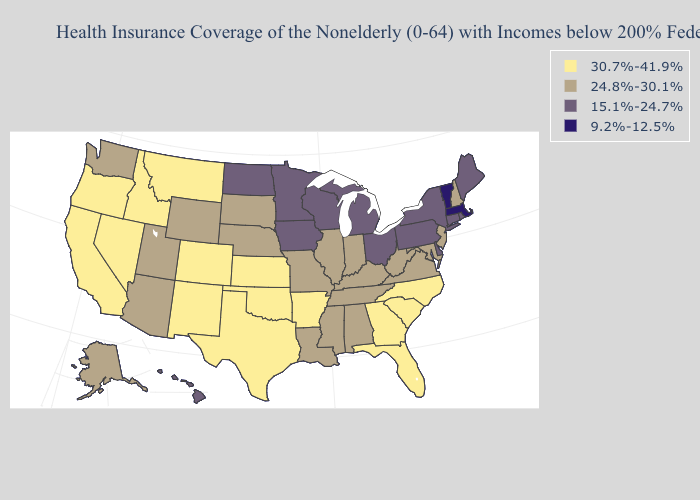Name the states that have a value in the range 9.2%-12.5%?
Be succinct. Massachusetts, Vermont. What is the lowest value in states that border North Dakota?
Write a very short answer. 15.1%-24.7%. What is the highest value in the South ?
Short answer required. 30.7%-41.9%. What is the value of Minnesota?
Write a very short answer. 15.1%-24.7%. Which states have the lowest value in the MidWest?
Write a very short answer. Iowa, Michigan, Minnesota, North Dakota, Ohio, Wisconsin. What is the highest value in the USA?
Keep it brief. 30.7%-41.9%. Does the first symbol in the legend represent the smallest category?
Concise answer only. No. What is the highest value in the MidWest ?
Be succinct. 30.7%-41.9%. What is the value of Colorado?
Short answer required. 30.7%-41.9%. What is the lowest value in the South?
Answer briefly. 15.1%-24.7%. What is the lowest value in states that border Vermont?
Give a very brief answer. 9.2%-12.5%. Is the legend a continuous bar?
Give a very brief answer. No. Among the states that border Louisiana , which have the lowest value?
Write a very short answer. Mississippi. Is the legend a continuous bar?
Short answer required. No. Which states have the lowest value in the USA?
Concise answer only. Massachusetts, Vermont. 